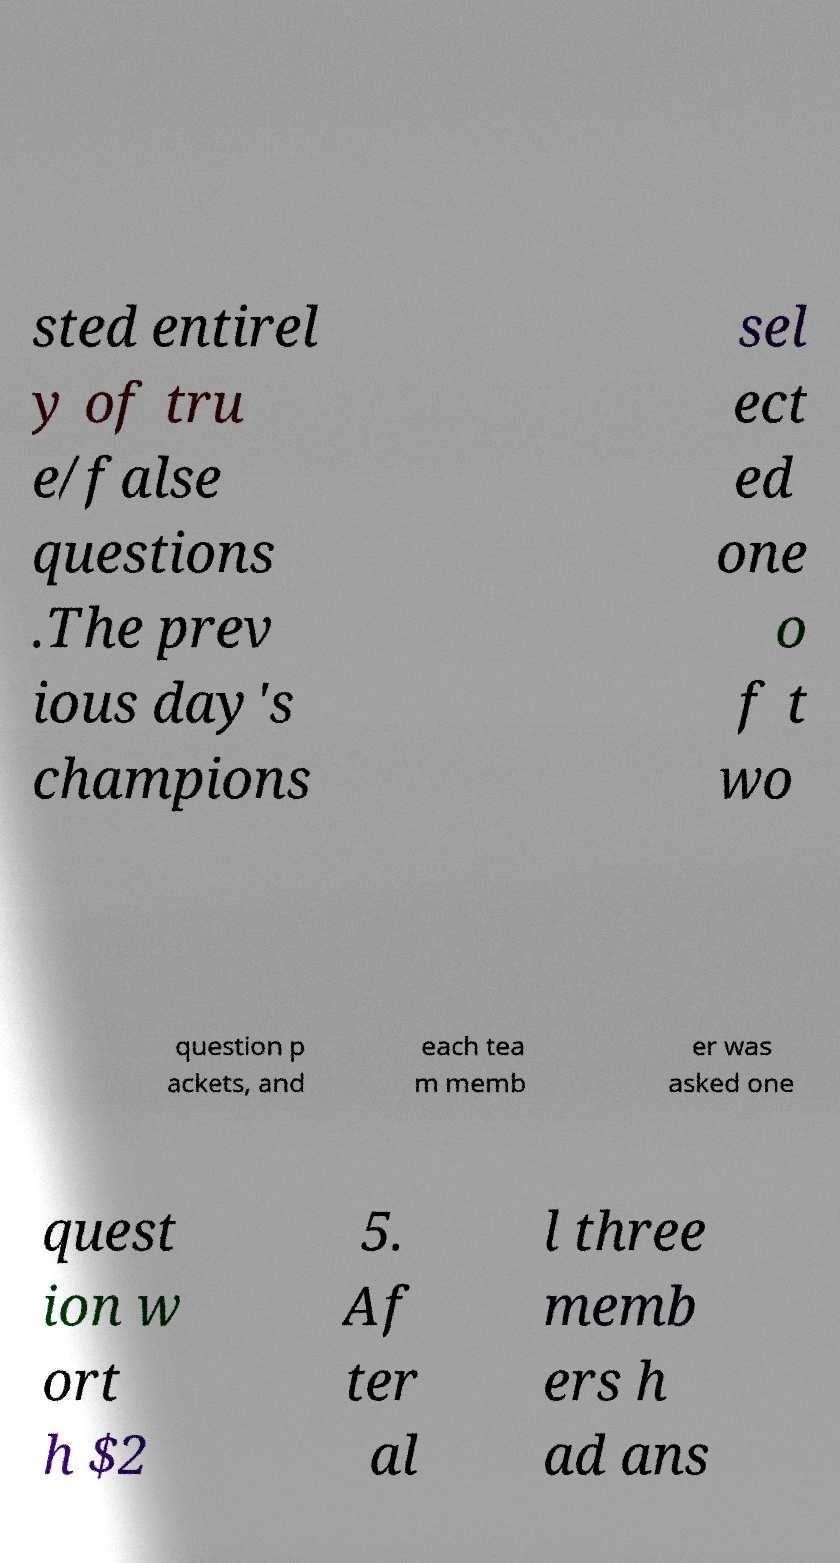Can you accurately transcribe the text from the provided image for me? sted entirel y of tru e/false questions .The prev ious day's champions sel ect ed one o f t wo question p ackets, and each tea m memb er was asked one quest ion w ort h $2 5. Af ter al l three memb ers h ad ans 